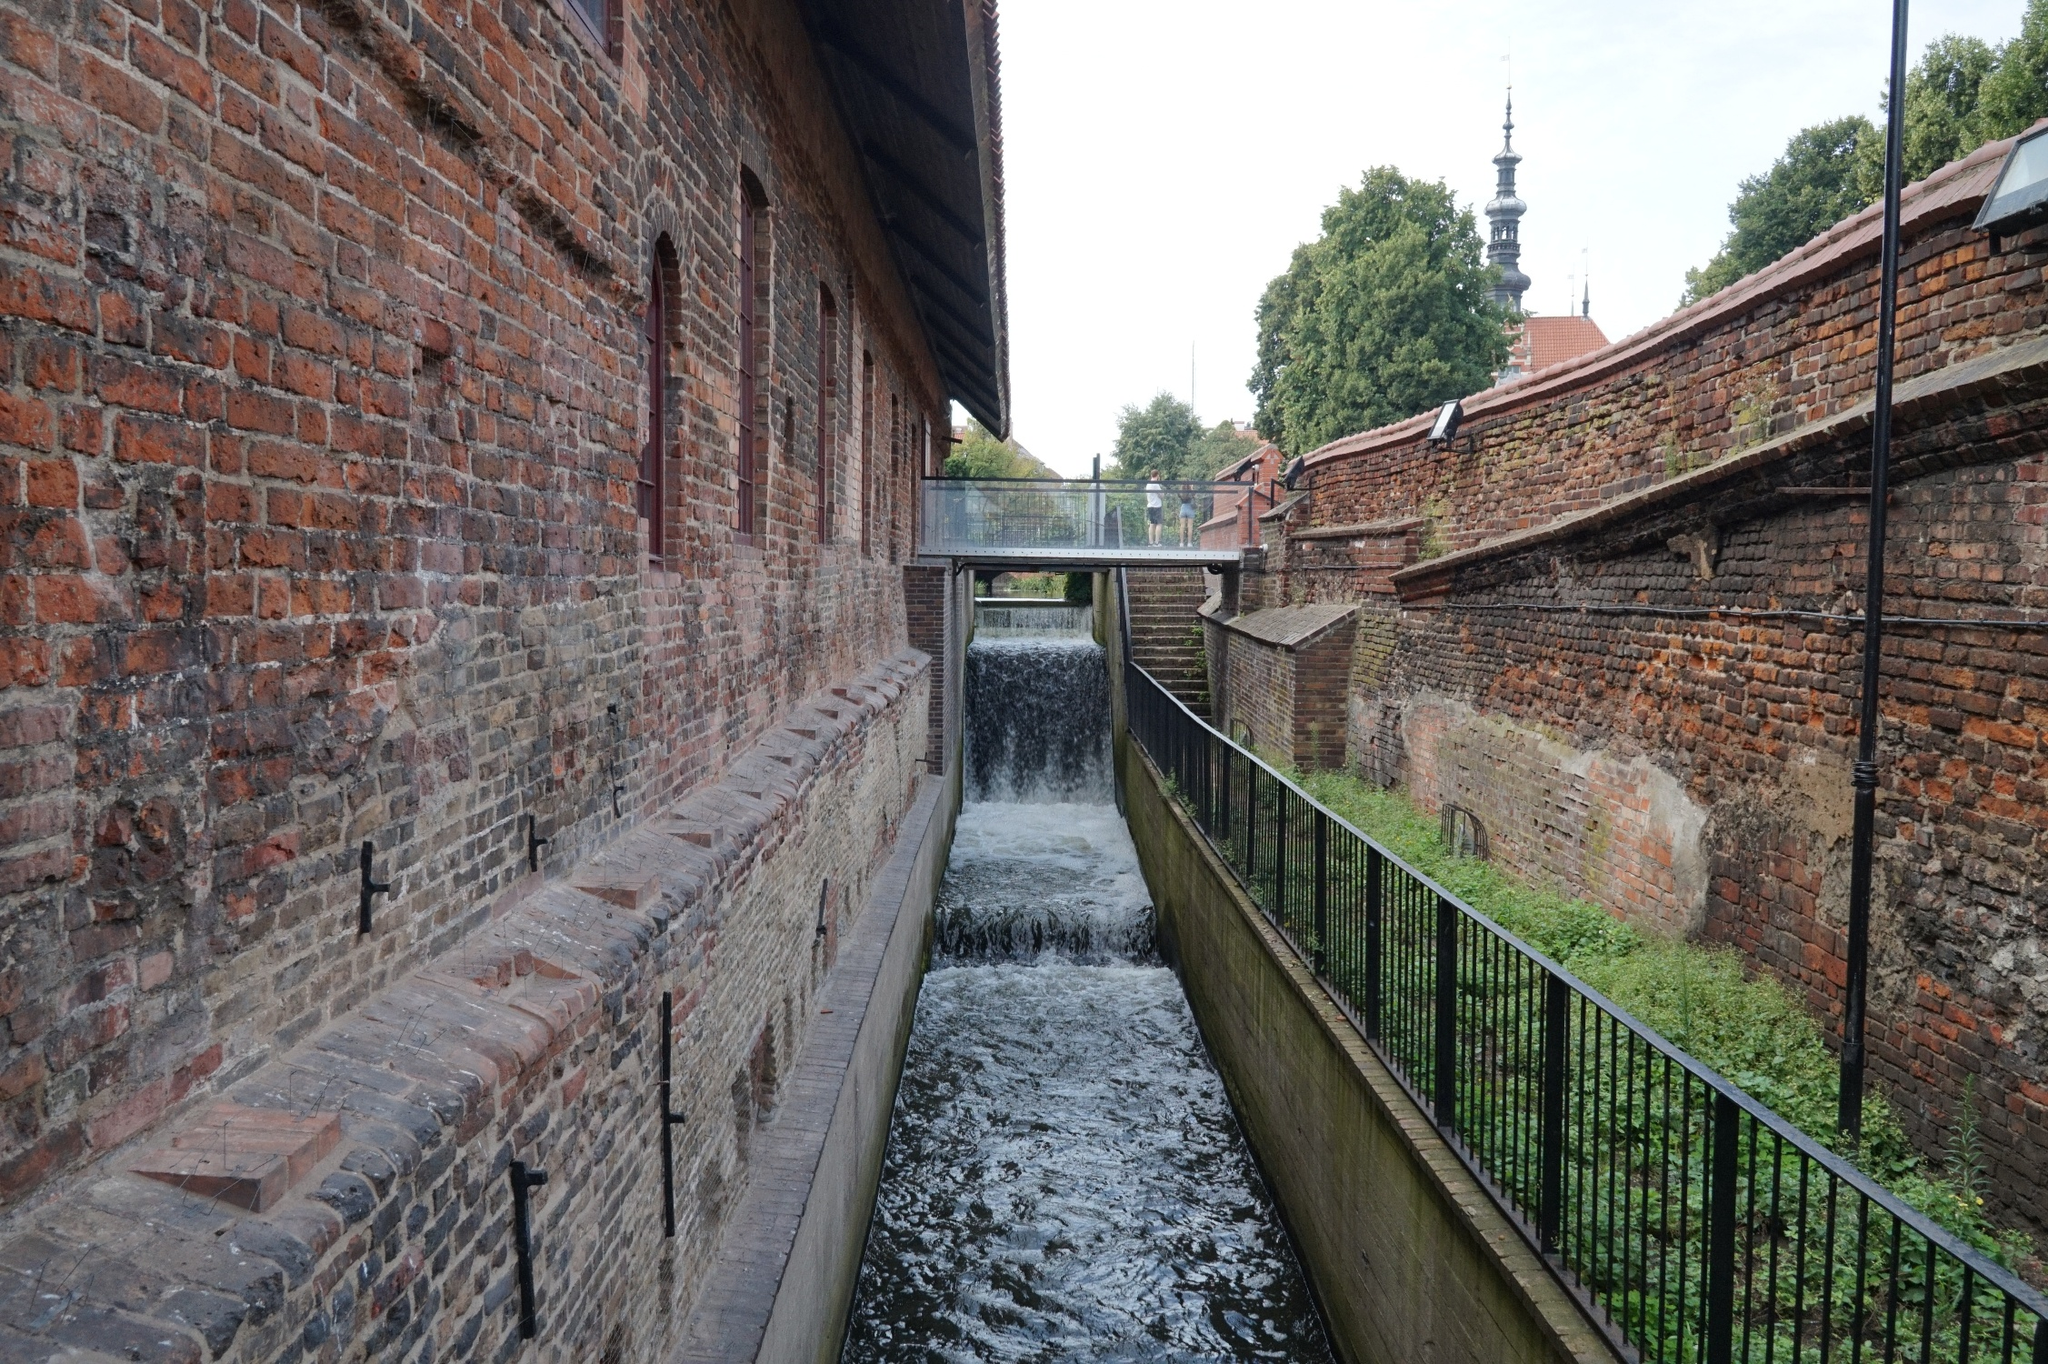If the canal could talk, what stories would it tell about this place over the years? If the canal could talk, it would weave tales of transformation and persistence. It would tell of the days long ago when it was first constructed, its waters guiding bustling trade ships through the heart of the town. It would recount stories of laborers and merchants who built their livelihoods along its banks, their sweat and toil shaping the town's economy. As industries rose and fell, the canal witnessed silent nights and vibrant days, echoing the town's spirit of endurance. It would whisper secrets of hidden romances on moonlit walks, echo the laughter of children playing along its banks, and share the quiet contemplation of countless souls drawn to its moving waters. Over the years, the canal has been a steadfast companion to Riverstone, witnessing its evolution while holding onto the essence of its history. 